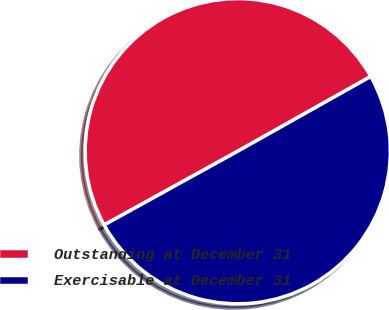Convert chart to OTSL. <chart><loc_0><loc_0><loc_500><loc_500><pie_chart><fcel>Outstanding at December 31<fcel>Exercisable at December 31<nl><fcel>49.88%<fcel>50.12%<nl></chart> 